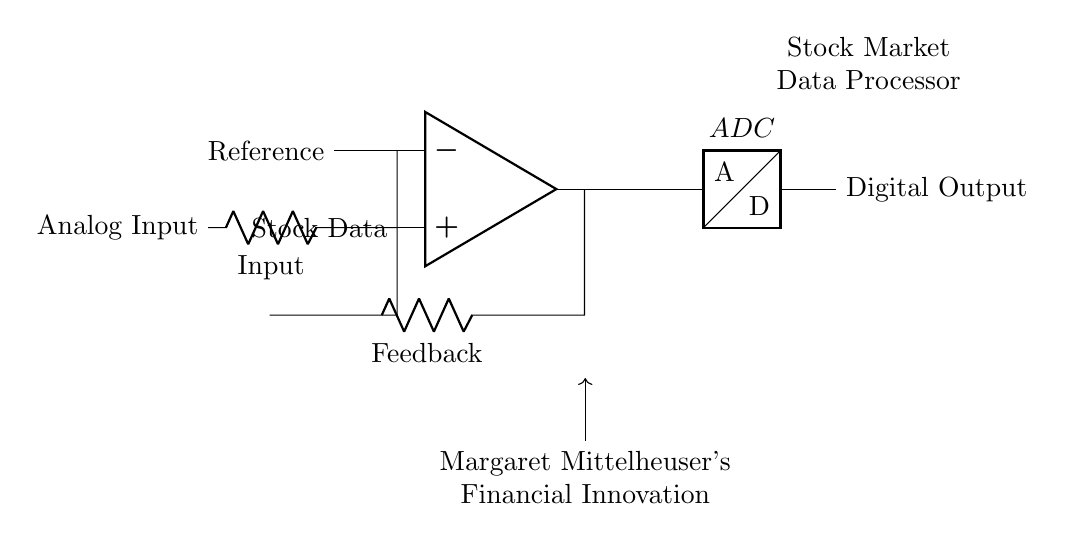What type of component is labeled as ADC? The label ADC indicates that the component is an Analog-to-Digital Converter, a critical part of processing analog signals into digital form for further analysis.
Answer: Analog-to-Digital Converter What is the purpose of the feedback resistor in this circuit? The feedback resistor plays a significant role in controlling the gain of the operational amplifier, affecting how the input voltage is processed and ensuring stability in the output.
Answer: Control gain What does the input labeled "Stock Data" represent? The input "Stock Data" is the analog signal that is being converted into a digital format for further processing, representing real-time stock market data.
Answer: Real-time stock market data Which two components serve as inputs to the operational amplifier? The operational amplifier receives input from two sources: the analog input (where stock data comes in) and the reference voltage, which compares against the signal to maintain accuracy.
Answer: Stock Data and Reference What is the role of the operational amplifier in this circuit? The operational amplifier amplifies the difference between the input voltage from the stock data and the reference voltage, producing an output that is then fed into the ADC for conversion.
Answer: Amplification How does the operational amplifier influence the digital output? The operational amplifier adjusts the analog signal based on feedback and inputs, providing a proportionate output that the ADC converts into a digital format for further use or analysis.
Answer: Proportionate output What signifies the connection marked as "Margaret Mittelheuser's Financial Innovation"? This connection references an influence or input related to financial technologies or methodologies inspired by Margaret Mittelheuser, indicating a conceptual input into the circuit's design or purpose.
Answer: Conceptual input 